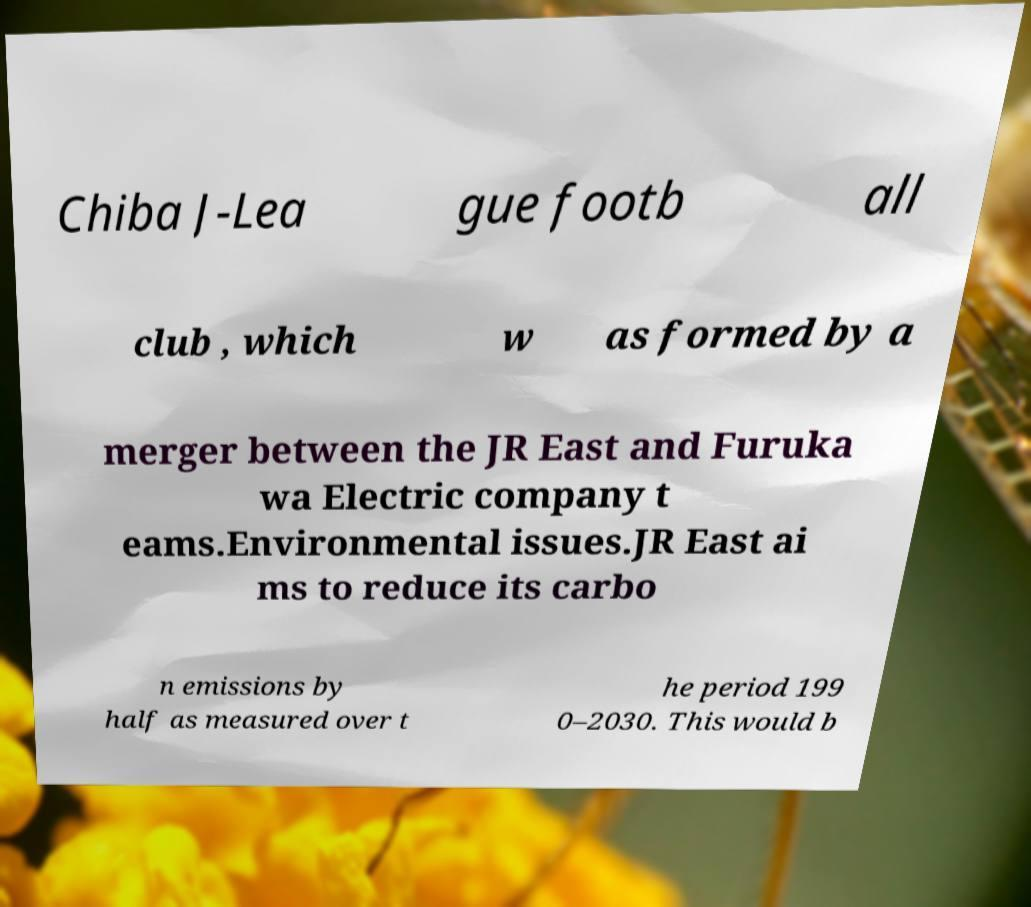There's text embedded in this image that I need extracted. Can you transcribe it verbatim? Chiba J-Lea gue footb all club , which w as formed by a merger between the JR East and Furuka wa Electric company t eams.Environmental issues.JR East ai ms to reduce its carbo n emissions by half as measured over t he period 199 0–2030. This would b 